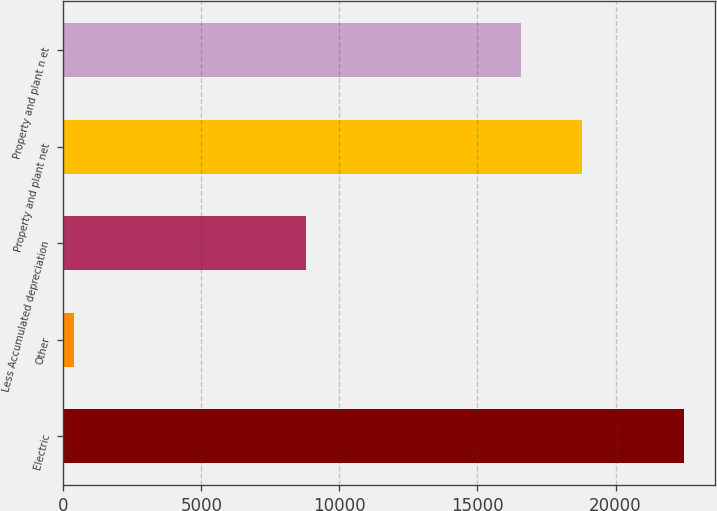<chart> <loc_0><loc_0><loc_500><loc_500><bar_chart><fcel>Electric<fcel>Other<fcel>Less Accumulated depreciation<fcel>Property and plant net<fcel>Property and plant n et<nl><fcel>22486<fcel>406<fcel>8787<fcel>18775<fcel>16567<nl></chart> 